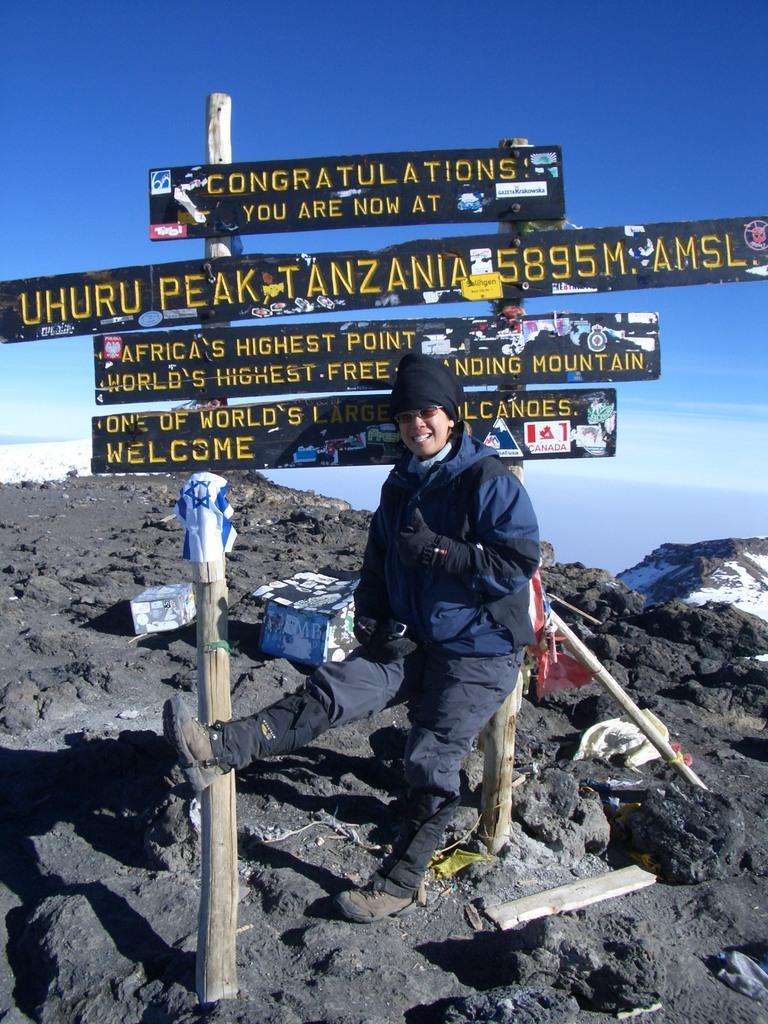Describe this image in one or two sentences. As we can see in the image there is a sign board, a person wearing blue color jacket, hills and sky. 